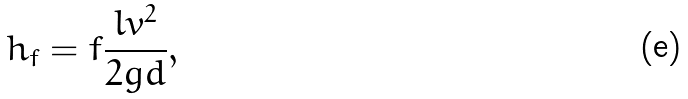<formula> <loc_0><loc_0><loc_500><loc_500>h _ { f } = f \frac { l v ^ { 2 } } { 2 g d } ,</formula> 